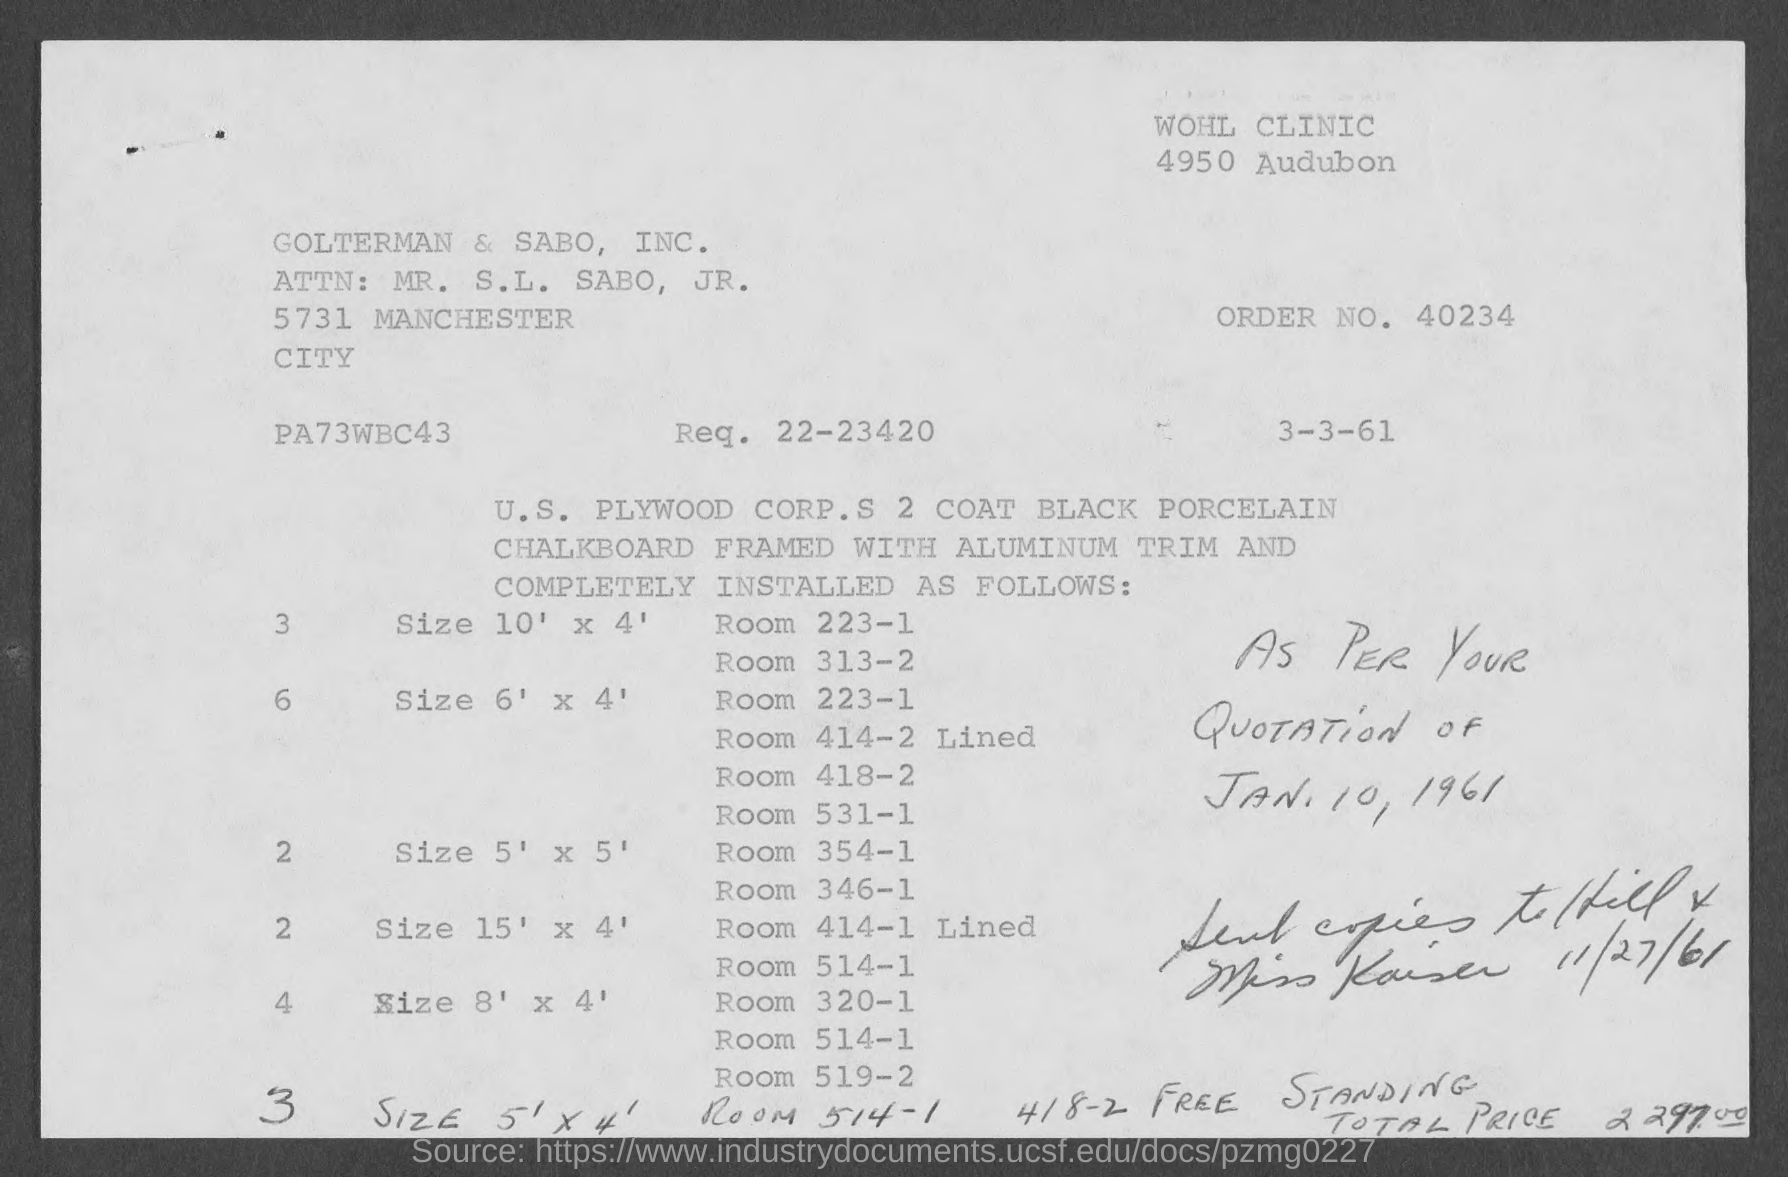What is the order no.?
Give a very brief answer. 40234. What is the Req. ?
Your response must be concise. 22-23420. 